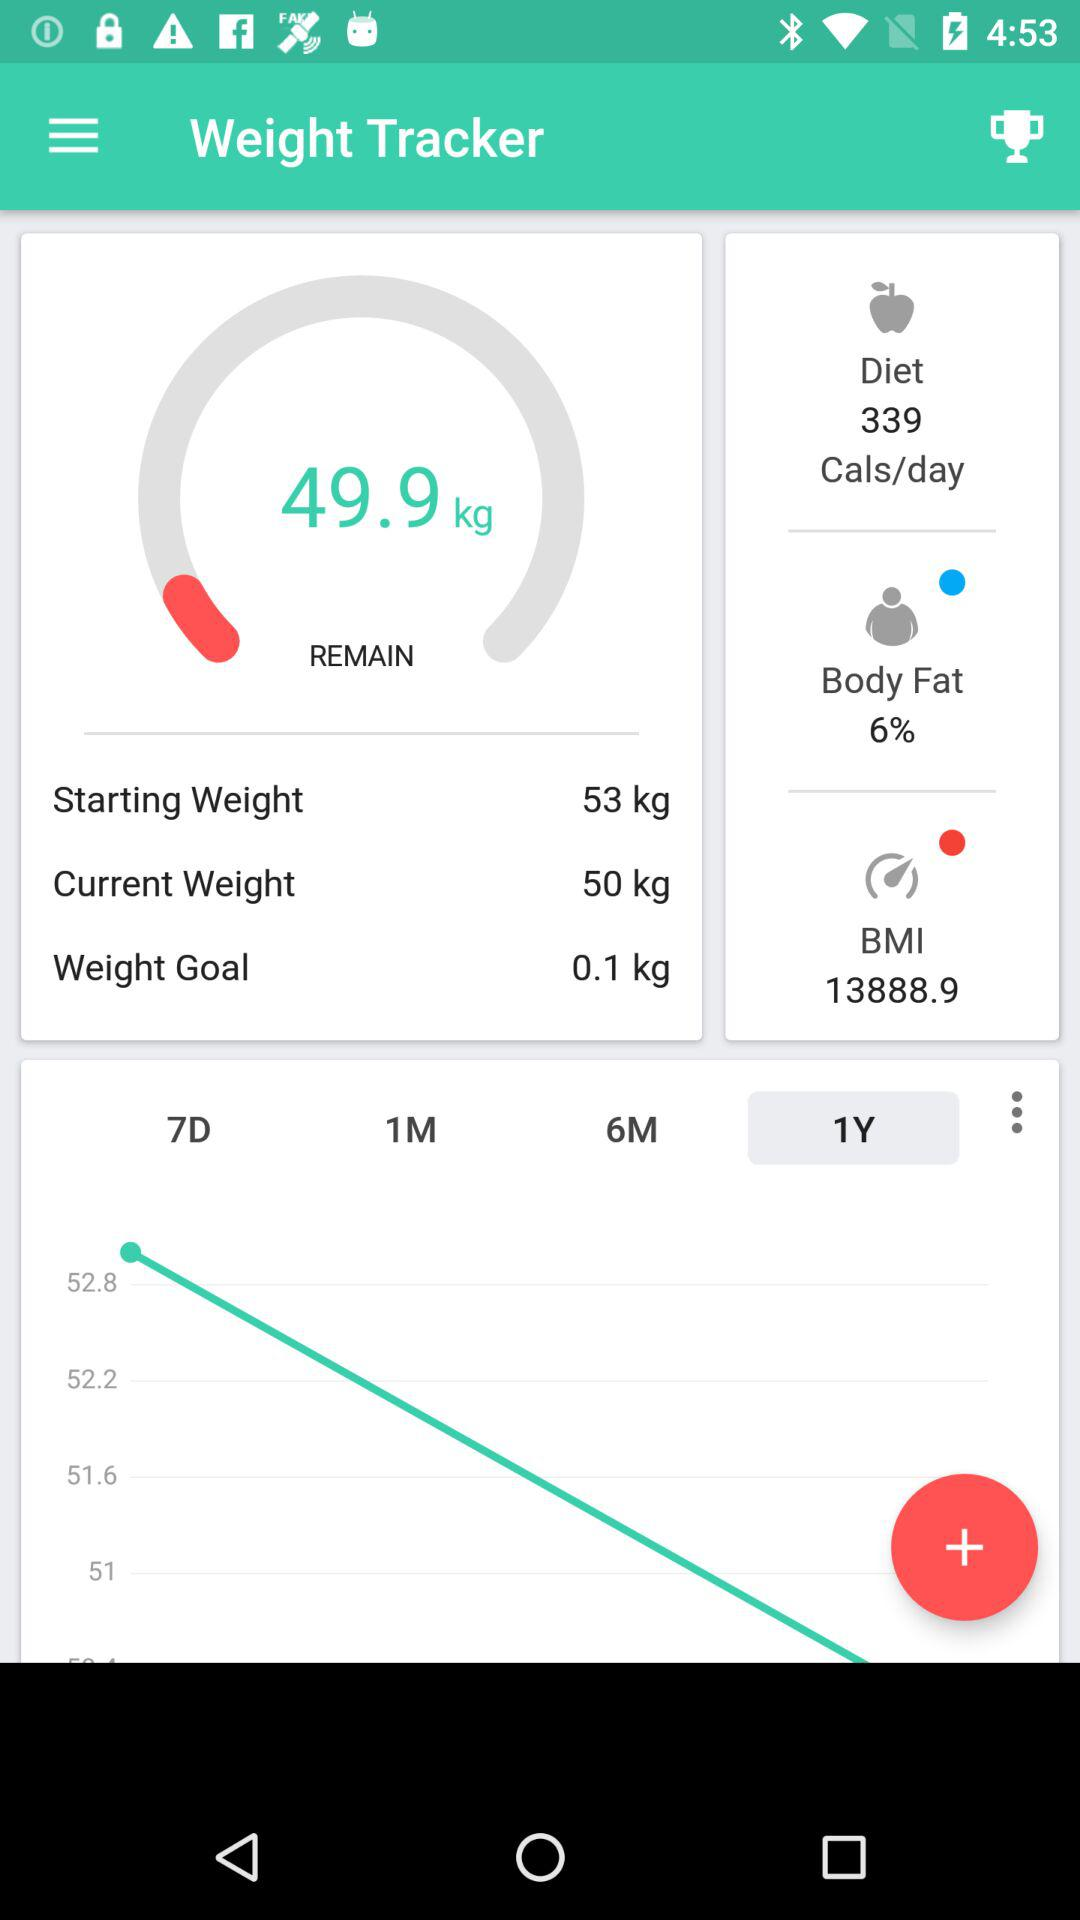How much more weight do I need to lose to reach my goal weight?
Answer the question using a single word or phrase. 0.1 kg 